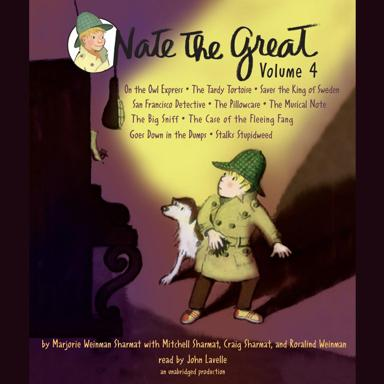What does the presence of the dog on the cover suggest about the stories in 'Nate The Great Volume 4'? The dog on the cover of 'Nate The Great Volume 4' likely represents the character's sidekick, aiding in his investigative adventures. It suggests that themes of friendship, loyalty, and teamwork are integral to the stories, as they help solve mysteries together. 